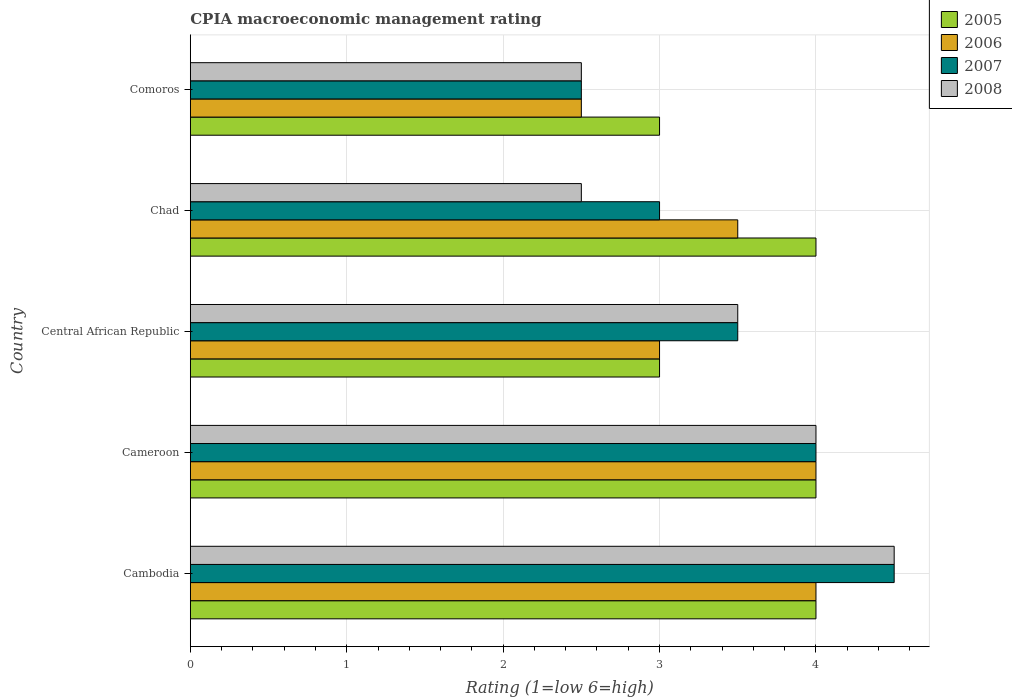Are the number of bars on each tick of the Y-axis equal?
Provide a short and direct response. Yes. How many bars are there on the 4th tick from the top?
Your response must be concise. 4. What is the label of the 1st group of bars from the top?
Your answer should be compact. Comoros. What is the CPIA rating in 2005 in Cameroon?
Provide a succinct answer. 4. In which country was the CPIA rating in 2008 maximum?
Your answer should be compact. Cambodia. In which country was the CPIA rating in 2007 minimum?
Your answer should be very brief. Comoros. What is the total CPIA rating in 2006 in the graph?
Provide a succinct answer. 17. What is the difference between the CPIA rating in 2006 in Chad and the CPIA rating in 2008 in Comoros?
Offer a very short reply. 1. What is the difference between the CPIA rating in 2005 and CPIA rating in 2007 in Cambodia?
Your answer should be compact. -0.5. In how many countries, is the CPIA rating in 2007 greater than 2.6 ?
Your answer should be compact. 4. Is the CPIA rating in 2007 in Cameroon less than that in Chad?
Provide a succinct answer. No. What is the difference between the highest and the lowest CPIA rating in 2007?
Make the answer very short. 2. Is the sum of the CPIA rating in 2007 in Cameroon and Chad greater than the maximum CPIA rating in 2008 across all countries?
Keep it short and to the point. Yes. Is it the case that in every country, the sum of the CPIA rating in 2005 and CPIA rating in 2008 is greater than the sum of CPIA rating in 2007 and CPIA rating in 2006?
Give a very brief answer. No. Is it the case that in every country, the sum of the CPIA rating in 2007 and CPIA rating in 2006 is greater than the CPIA rating in 2008?
Your answer should be very brief. Yes. How many bars are there?
Your response must be concise. 20. Are all the bars in the graph horizontal?
Make the answer very short. Yes. Are the values on the major ticks of X-axis written in scientific E-notation?
Make the answer very short. No. Does the graph contain any zero values?
Give a very brief answer. No. Where does the legend appear in the graph?
Your response must be concise. Top right. How many legend labels are there?
Provide a short and direct response. 4. How are the legend labels stacked?
Keep it short and to the point. Vertical. What is the title of the graph?
Your response must be concise. CPIA macroeconomic management rating. Does "1980" appear as one of the legend labels in the graph?
Offer a very short reply. No. What is the label or title of the Y-axis?
Offer a terse response. Country. What is the Rating (1=low 6=high) of 2006 in Cambodia?
Give a very brief answer. 4. What is the Rating (1=low 6=high) in 2007 in Cambodia?
Offer a very short reply. 4.5. What is the Rating (1=low 6=high) of 2008 in Cambodia?
Give a very brief answer. 4.5. What is the Rating (1=low 6=high) in 2006 in Cameroon?
Your response must be concise. 4. What is the Rating (1=low 6=high) of 2007 in Cameroon?
Provide a short and direct response. 4. What is the Rating (1=low 6=high) of 2008 in Cameroon?
Make the answer very short. 4. What is the Rating (1=low 6=high) of 2005 in Central African Republic?
Ensure brevity in your answer.  3. What is the Rating (1=low 6=high) of 2008 in Chad?
Ensure brevity in your answer.  2.5. What is the Rating (1=low 6=high) of 2006 in Comoros?
Make the answer very short. 2.5. Across all countries, what is the maximum Rating (1=low 6=high) of 2005?
Your answer should be very brief. 4. Across all countries, what is the maximum Rating (1=low 6=high) of 2006?
Offer a terse response. 4. Across all countries, what is the maximum Rating (1=low 6=high) in 2008?
Make the answer very short. 4.5. What is the total Rating (1=low 6=high) in 2006 in the graph?
Provide a short and direct response. 17. What is the difference between the Rating (1=low 6=high) of 2006 in Cambodia and that in Cameroon?
Give a very brief answer. 0. What is the difference between the Rating (1=low 6=high) of 2008 in Cambodia and that in Cameroon?
Your answer should be compact. 0.5. What is the difference between the Rating (1=low 6=high) in 2005 in Cambodia and that in Central African Republic?
Offer a terse response. 1. What is the difference between the Rating (1=low 6=high) in 2007 in Cambodia and that in Central African Republic?
Ensure brevity in your answer.  1. What is the difference between the Rating (1=low 6=high) in 2008 in Cambodia and that in Central African Republic?
Offer a terse response. 1. What is the difference between the Rating (1=low 6=high) of 2006 in Cambodia and that in Chad?
Make the answer very short. 0.5. What is the difference between the Rating (1=low 6=high) in 2008 in Cambodia and that in Chad?
Provide a succinct answer. 2. What is the difference between the Rating (1=low 6=high) of 2005 in Cambodia and that in Comoros?
Your response must be concise. 1. What is the difference between the Rating (1=low 6=high) of 2008 in Cambodia and that in Comoros?
Offer a very short reply. 2. What is the difference between the Rating (1=low 6=high) of 2007 in Cameroon and that in Central African Republic?
Offer a terse response. 0.5. What is the difference between the Rating (1=low 6=high) in 2005 in Cameroon and that in Chad?
Make the answer very short. 0. What is the difference between the Rating (1=low 6=high) in 2006 in Cameroon and that in Chad?
Your answer should be very brief. 0.5. What is the difference between the Rating (1=low 6=high) in 2007 in Cameroon and that in Chad?
Provide a succinct answer. 1. What is the difference between the Rating (1=low 6=high) in 2008 in Cameroon and that in Chad?
Your answer should be compact. 1.5. What is the difference between the Rating (1=low 6=high) in 2005 in Cameroon and that in Comoros?
Ensure brevity in your answer.  1. What is the difference between the Rating (1=low 6=high) of 2006 in Central African Republic and that in Chad?
Your answer should be very brief. -0.5. What is the difference between the Rating (1=low 6=high) of 2006 in Central African Republic and that in Comoros?
Offer a very short reply. 0.5. What is the difference between the Rating (1=low 6=high) in 2007 in Central African Republic and that in Comoros?
Provide a succinct answer. 1. What is the difference between the Rating (1=low 6=high) of 2005 in Chad and that in Comoros?
Ensure brevity in your answer.  1. What is the difference between the Rating (1=low 6=high) in 2006 in Chad and that in Comoros?
Provide a short and direct response. 1. What is the difference between the Rating (1=low 6=high) in 2007 in Chad and that in Comoros?
Provide a short and direct response. 0.5. What is the difference between the Rating (1=low 6=high) in 2005 in Cambodia and the Rating (1=low 6=high) in 2006 in Cameroon?
Offer a very short reply. 0. What is the difference between the Rating (1=low 6=high) in 2005 in Cambodia and the Rating (1=low 6=high) in 2008 in Cameroon?
Make the answer very short. 0. What is the difference between the Rating (1=low 6=high) of 2006 in Cambodia and the Rating (1=low 6=high) of 2008 in Cameroon?
Make the answer very short. 0. What is the difference between the Rating (1=low 6=high) in 2005 in Cambodia and the Rating (1=low 6=high) in 2007 in Central African Republic?
Offer a terse response. 0.5. What is the difference between the Rating (1=low 6=high) of 2006 in Cambodia and the Rating (1=low 6=high) of 2007 in Central African Republic?
Offer a terse response. 0.5. What is the difference between the Rating (1=low 6=high) of 2006 in Cambodia and the Rating (1=low 6=high) of 2008 in Central African Republic?
Your answer should be very brief. 0.5. What is the difference between the Rating (1=low 6=high) of 2007 in Cambodia and the Rating (1=low 6=high) of 2008 in Central African Republic?
Give a very brief answer. 1. What is the difference between the Rating (1=low 6=high) of 2005 in Cambodia and the Rating (1=low 6=high) of 2006 in Chad?
Offer a very short reply. 0.5. What is the difference between the Rating (1=low 6=high) of 2005 in Cambodia and the Rating (1=low 6=high) of 2008 in Chad?
Ensure brevity in your answer.  1.5. What is the difference between the Rating (1=low 6=high) of 2007 in Cambodia and the Rating (1=low 6=high) of 2008 in Chad?
Your response must be concise. 2. What is the difference between the Rating (1=low 6=high) in 2005 in Cambodia and the Rating (1=low 6=high) in 2006 in Comoros?
Your response must be concise. 1.5. What is the difference between the Rating (1=low 6=high) in 2006 in Cambodia and the Rating (1=low 6=high) in 2007 in Comoros?
Provide a short and direct response. 1.5. What is the difference between the Rating (1=low 6=high) of 2007 in Cambodia and the Rating (1=low 6=high) of 2008 in Comoros?
Offer a very short reply. 2. What is the difference between the Rating (1=low 6=high) of 2005 in Cameroon and the Rating (1=low 6=high) of 2006 in Central African Republic?
Your answer should be compact. 1. What is the difference between the Rating (1=low 6=high) in 2005 in Cameroon and the Rating (1=low 6=high) in 2007 in Central African Republic?
Give a very brief answer. 0.5. What is the difference between the Rating (1=low 6=high) of 2007 in Cameroon and the Rating (1=low 6=high) of 2008 in Central African Republic?
Offer a terse response. 0.5. What is the difference between the Rating (1=low 6=high) of 2005 in Cameroon and the Rating (1=low 6=high) of 2006 in Chad?
Your response must be concise. 0.5. What is the difference between the Rating (1=low 6=high) of 2006 in Cameroon and the Rating (1=low 6=high) of 2007 in Chad?
Your response must be concise. 1. What is the difference between the Rating (1=low 6=high) of 2006 in Cameroon and the Rating (1=low 6=high) of 2008 in Chad?
Give a very brief answer. 1.5. What is the difference between the Rating (1=low 6=high) in 2007 in Cameroon and the Rating (1=low 6=high) in 2008 in Chad?
Offer a very short reply. 1.5. What is the difference between the Rating (1=low 6=high) in 2005 in Cameroon and the Rating (1=low 6=high) in 2006 in Comoros?
Your response must be concise. 1.5. What is the difference between the Rating (1=low 6=high) in 2005 in Cameroon and the Rating (1=low 6=high) in 2007 in Comoros?
Give a very brief answer. 1.5. What is the difference between the Rating (1=low 6=high) of 2006 in Cameroon and the Rating (1=low 6=high) of 2007 in Comoros?
Give a very brief answer. 1.5. What is the difference between the Rating (1=low 6=high) in 2005 in Central African Republic and the Rating (1=low 6=high) in 2006 in Chad?
Give a very brief answer. -0.5. What is the difference between the Rating (1=low 6=high) of 2006 in Central African Republic and the Rating (1=low 6=high) of 2008 in Chad?
Keep it short and to the point. 0.5. What is the difference between the Rating (1=low 6=high) of 2005 in Central African Republic and the Rating (1=low 6=high) of 2006 in Comoros?
Your response must be concise. 0.5. What is the difference between the Rating (1=low 6=high) of 2005 in Central African Republic and the Rating (1=low 6=high) of 2007 in Comoros?
Give a very brief answer. 0.5. What is the difference between the Rating (1=low 6=high) in 2005 in Central African Republic and the Rating (1=low 6=high) in 2008 in Comoros?
Keep it short and to the point. 0.5. What is the difference between the Rating (1=low 6=high) in 2007 in Central African Republic and the Rating (1=low 6=high) in 2008 in Comoros?
Your response must be concise. 1. What is the difference between the Rating (1=low 6=high) of 2005 in Chad and the Rating (1=low 6=high) of 2007 in Comoros?
Make the answer very short. 1.5. What is the difference between the Rating (1=low 6=high) in 2006 in Chad and the Rating (1=low 6=high) in 2007 in Comoros?
Provide a succinct answer. 1. What is the difference between the Rating (1=low 6=high) of 2006 in Chad and the Rating (1=low 6=high) of 2008 in Comoros?
Keep it short and to the point. 1. What is the difference between the Rating (1=low 6=high) of 2007 in Chad and the Rating (1=low 6=high) of 2008 in Comoros?
Make the answer very short. 0.5. What is the average Rating (1=low 6=high) in 2006 per country?
Offer a terse response. 3.4. What is the difference between the Rating (1=low 6=high) of 2005 and Rating (1=low 6=high) of 2006 in Cambodia?
Your response must be concise. 0. What is the difference between the Rating (1=low 6=high) of 2007 and Rating (1=low 6=high) of 2008 in Cambodia?
Make the answer very short. 0. What is the difference between the Rating (1=low 6=high) of 2005 and Rating (1=low 6=high) of 2006 in Cameroon?
Make the answer very short. 0. What is the difference between the Rating (1=low 6=high) in 2005 and Rating (1=low 6=high) in 2007 in Cameroon?
Give a very brief answer. 0. What is the difference between the Rating (1=low 6=high) of 2006 and Rating (1=low 6=high) of 2007 in Cameroon?
Your response must be concise. 0. What is the difference between the Rating (1=low 6=high) of 2006 and Rating (1=low 6=high) of 2008 in Cameroon?
Your answer should be very brief. 0. What is the difference between the Rating (1=low 6=high) in 2005 and Rating (1=low 6=high) in 2007 in Central African Republic?
Provide a short and direct response. -0.5. What is the difference between the Rating (1=low 6=high) in 2005 and Rating (1=low 6=high) in 2008 in Central African Republic?
Your answer should be very brief. -0.5. What is the difference between the Rating (1=low 6=high) in 2006 and Rating (1=low 6=high) in 2007 in Central African Republic?
Provide a succinct answer. -0.5. What is the difference between the Rating (1=low 6=high) of 2006 and Rating (1=low 6=high) of 2008 in Central African Republic?
Give a very brief answer. -0.5. What is the difference between the Rating (1=low 6=high) in 2007 and Rating (1=low 6=high) in 2008 in Central African Republic?
Your answer should be very brief. 0. What is the difference between the Rating (1=low 6=high) of 2005 and Rating (1=low 6=high) of 2006 in Chad?
Make the answer very short. 0.5. What is the difference between the Rating (1=low 6=high) in 2005 and Rating (1=low 6=high) in 2007 in Chad?
Provide a short and direct response. 1. What is the difference between the Rating (1=low 6=high) in 2005 and Rating (1=low 6=high) in 2008 in Chad?
Provide a succinct answer. 1.5. What is the difference between the Rating (1=low 6=high) in 2006 and Rating (1=low 6=high) in 2008 in Chad?
Offer a terse response. 1. What is the difference between the Rating (1=low 6=high) of 2006 and Rating (1=low 6=high) of 2007 in Comoros?
Your response must be concise. 0. What is the difference between the Rating (1=low 6=high) in 2006 and Rating (1=low 6=high) in 2008 in Comoros?
Make the answer very short. 0. What is the difference between the Rating (1=low 6=high) in 2007 and Rating (1=low 6=high) in 2008 in Comoros?
Provide a short and direct response. 0. What is the ratio of the Rating (1=low 6=high) of 2005 in Cambodia to that in Cameroon?
Your answer should be very brief. 1. What is the ratio of the Rating (1=low 6=high) in 2007 in Cambodia to that in Cameroon?
Your answer should be compact. 1.12. What is the ratio of the Rating (1=low 6=high) of 2008 in Cambodia to that in Cameroon?
Make the answer very short. 1.12. What is the ratio of the Rating (1=low 6=high) in 2005 in Cambodia to that in Central African Republic?
Your response must be concise. 1.33. What is the ratio of the Rating (1=low 6=high) in 2006 in Cambodia to that in Central African Republic?
Your answer should be very brief. 1.33. What is the ratio of the Rating (1=low 6=high) in 2006 in Cameroon to that in Central African Republic?
Provide a succinct answer. 1.33. What is the ratio of the Rating (1=low 6=high) in 2007 in Cameroon to that in Central African Republic?
Offer a terse response. 1.14. What is the ratio of the Rating (1=low 6=high) in 2008 in Cameroon to that in Central African Republic?
Offer a very short reply. 1.14. What is the ratio of the Rating (1=low 6=high) of 2006 in Cameroon to that in Chad?
Offer a very short reply. 1.14. What is the ratio of the Rating (1=low 6=high) in 2007 in Cameroon to that in Chad?
Keep it short and to the point. 1.33. What is the ratio of the Rating (1=low 6=high) in 2008 in Cameroon to that in Chad?
Your response must be concise. 1.6. What is the ratio of the Rating (1=low 6=high) of 2005 in Cameroon to that in Comoros?
Provide a succinct answer. 1.33. What is the ratio of the Rating (1=low 6=high) in 2007 in Cameroon to that in Comoros?
Your answer should be very brief. 1.6. What is the ratio of the Rating (1=low 6=high) of 2005 in Central African Republic to that in Chad?
Your response must be concise. 0.75. What is the ratio of the Rating (1=low 6=high) of 2008 in Central African Republic to that in Chad?
Your response must be concise. 1.4. What is the ratio of the Rating (1=low 6=high) in 2005 in Central African Republic to that in Comoros?
Make the answer very short. 1. What is the ratio of the Rating (1=low 6=high) of 2006 in Central African Republic to that in Comoros?
Provide a succinct answer. 1.2. What is the ratio of the Rating (1=low 6=high) of 2008 in Central African Republic to that in Comoros?
Provide a short and direct response. 1.4. What is the ratio of the Rating (1=low 6=high) in 2007 in Chad to that in Comoros?
Make the answer very short. 1.2. What is the ratio of the Rating (1=low 6=high) in 2008 in Chad to that in Comoros?
Give a very brief answer. 1. What is the difference between the highest and the second highest Rating (1=low 6=high) of 2007?
Provide a succinct answer. 0.5. What is the difference between the highest and the second highest Rating (1=low 6=high) in 2008?
Your response must be concise. 0.5. What is the difference between the highest and the lowest Rating (1=low 6=high) in 2007?
Provide a succinct answer. 2. 